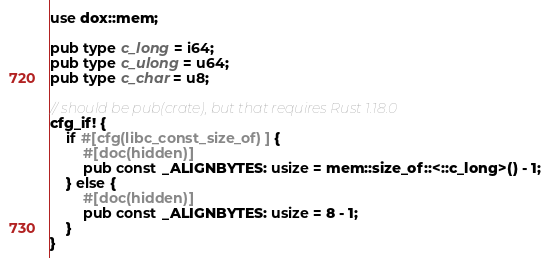<code> <loc_0><loc_0><loc_500><loc_500><_Rust_>use dox::mem;

pub type c_long = i64;
pub type c_ulong = u64;
pub type c_char = u8;

// should be pub(crate), but that requires Rust 1.18.0
cfg_if! {
    if #[cfg(libc_const_size_of)] {
        #[doc(hidden)]
        pub const _ALIGNBYTES: usize = mem::size_of::<::c_long>() - 1;
    } else {
        #[doc(hidden)]
        pub const _ALIGNBYTES: usize = 8 - 1;
    }
}
</code> 